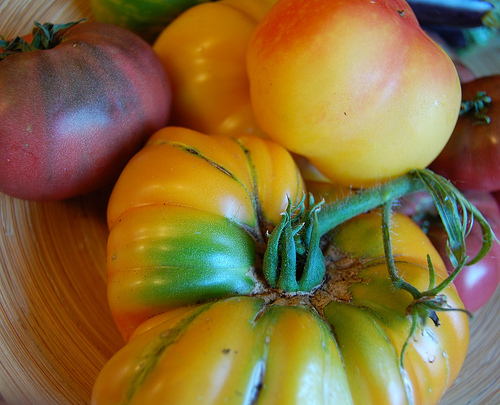<image>
Can you confirm if the tomato is on the stem? Yes. Looking at the image, I can see the tomato is positioned on top of the stem, with the stem providing support. 